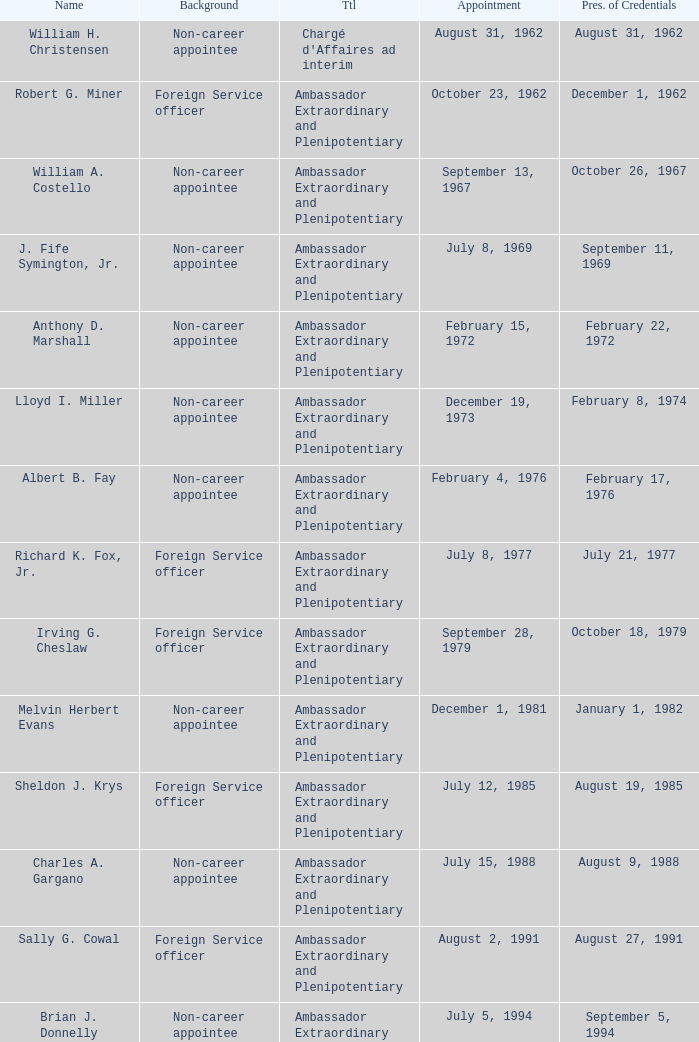When was William A. Costello appointed? September 13, 1967. 